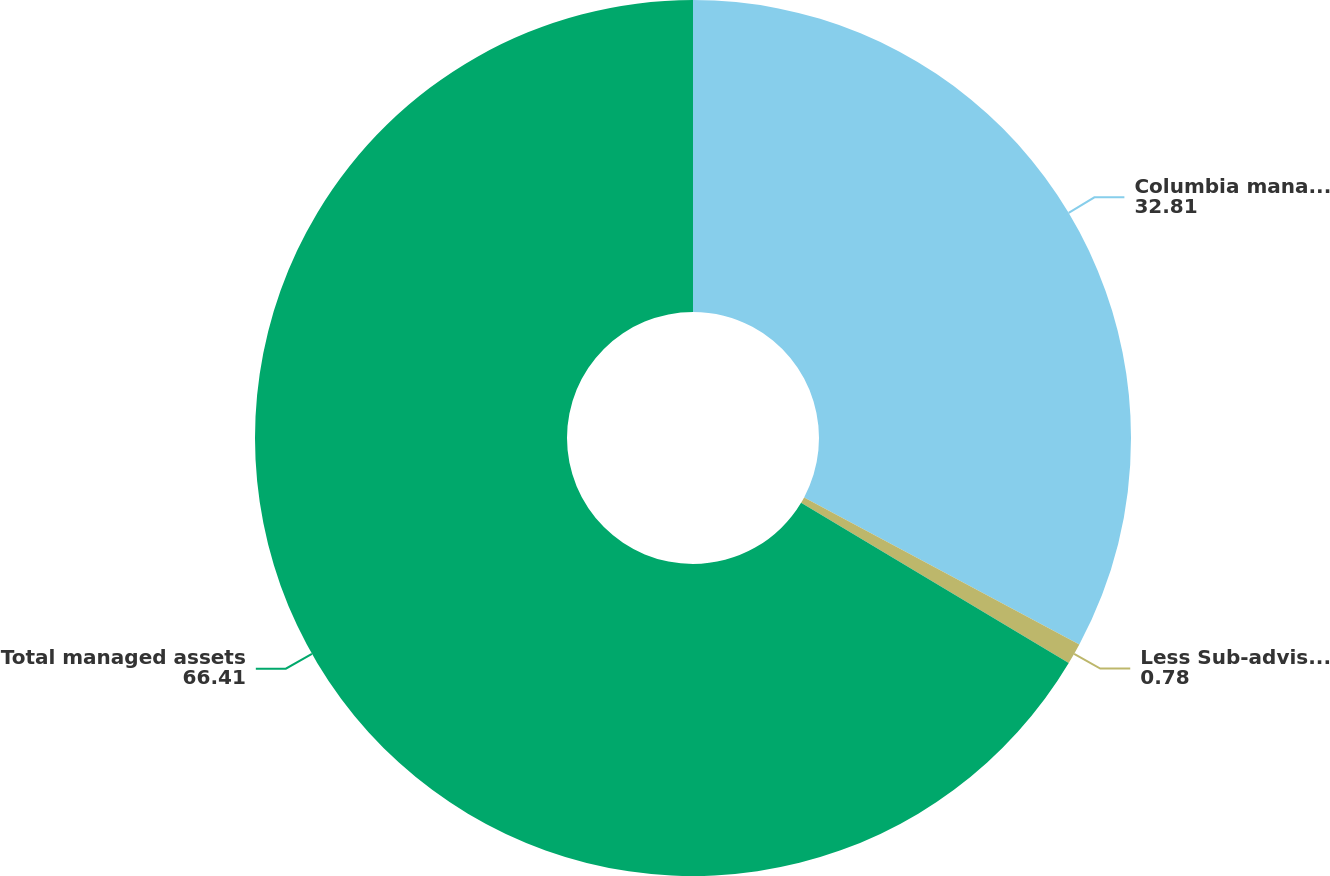<chart> <loc_0><loc_0><loc_500><loc_500><pie_chart><fcel>Columbia managed assets<fcel>Less Sub-advised eliminations<fcel>Total managed assets<nl><fcel>32.81%<fcel>0.78%<fcel>66.41%<nl></chart> 